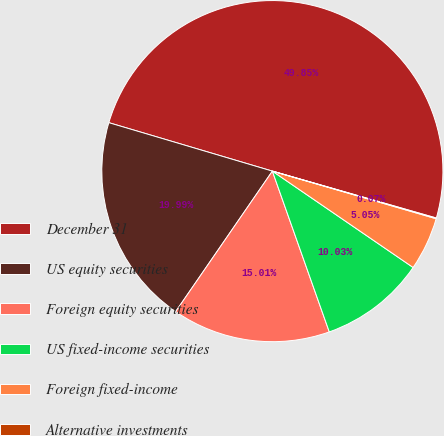<chart> <loc_0><loc_0><loc_500><loc_500><pie_chart><fcel>December 31<fcel>US equity securities<fcel>Foreign equity securities<fcel>US fixed-income securities<fcel>Foreign fixed-income<fcel>Alternative investments<nl><fcel>49.85%<fcel>19.99%<fcel>15.01%<fcel>10.03%<fcel>5.05%<fcel>0.07%<nl></chart> 